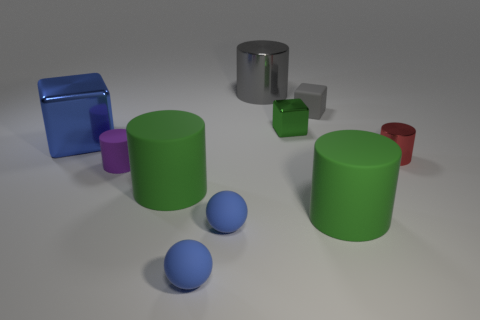Subtract all purple cylinders. How many cylinders are left? 4 Subtract all yellow cylinders. Subtract all yellow blocks. How many cylinders are left? 5 Subtract all balls. How many objects are left? 8 Add 3 blue shiny things. How many blue shiny things exist? 4 Subtract 1 blue cubes. How many objects are left? 9 Subtract all matte things. Subtract all big purple matte spheres. How many objects are left? 4 Add 8 red metal things. How many red metal things are left? 9 